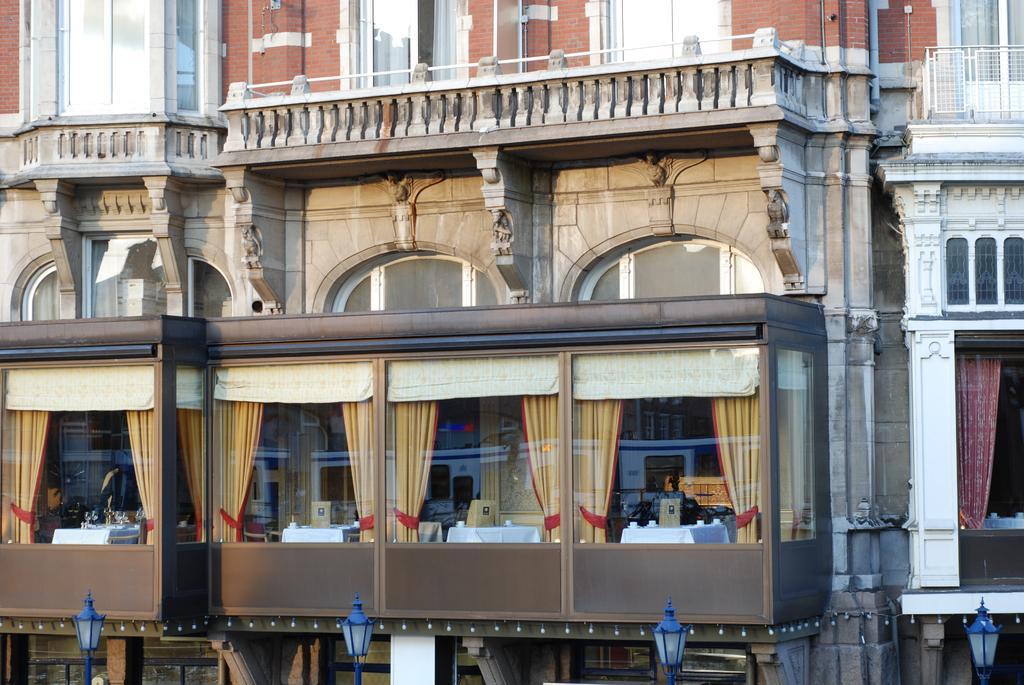Could you give a brief overview of what you see in this image? In this image I can see the light poles and buildings. I can see there are glass windows and railing to the building. Through the glass I can see the curtains and many tables. 